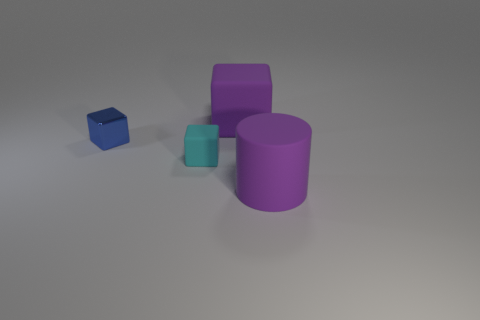Is there anything else that is the same material as the small blue cube?
Give a very brief answer. No. There is a block that is to the right of the cyan matte object; what material is it?
Your response must be concise. Rubber. Is the number of large cylinders behind the cyan cube the same as the number of big yellow spheres?
Provide a succinct answer. Yes. Is there any other thing that is the same color as the large cylinder?
Provide a succinct answer. Yes. There is a object that is both on the right side of the small cyan thing and behind the cyan rubber cube; what shape is it?
Provide a succinct answer. Cube. Are there an equal number of cyan things on the right side of the tiny cyan matte block and blue metal blocks behind the small blue metallic block?
Your response must be concise. Yes. What number of balls are either big things or large brown metallic objects?
Provide a short and direct response. 0. How many purple blocks have the same material as the purple cylinder?
Ensure brevity in your answer.  1. The object that is the same color as the matte cylinder is what shape?
Provide a succinct answer. Cube. There is a object that is on the left side of the large purple rubber cube and behind the small cyan matte block; what is its material?
Provide a succinct answer. Metal. 